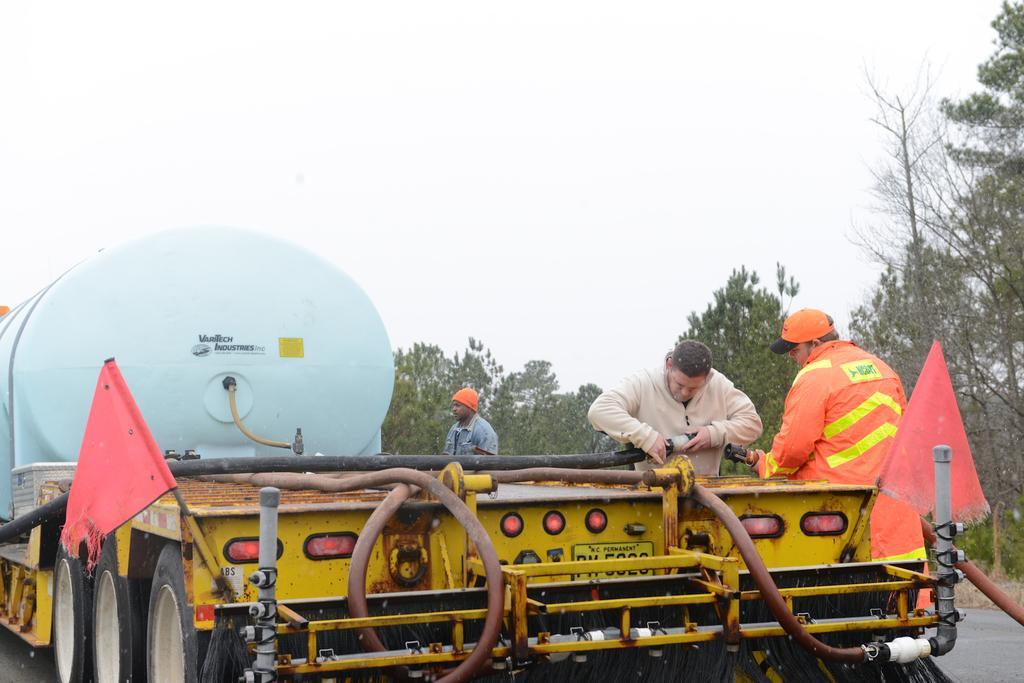Describe this image in one or two sentences. In this image we can see some people standing on the ground. Two men are holding pipes in their hands. On the left side of the image we can see a vehicle with some pipes, poles and some flags. On the right side of the image we can see a group of trees. At the top of the image we can see the sky. 